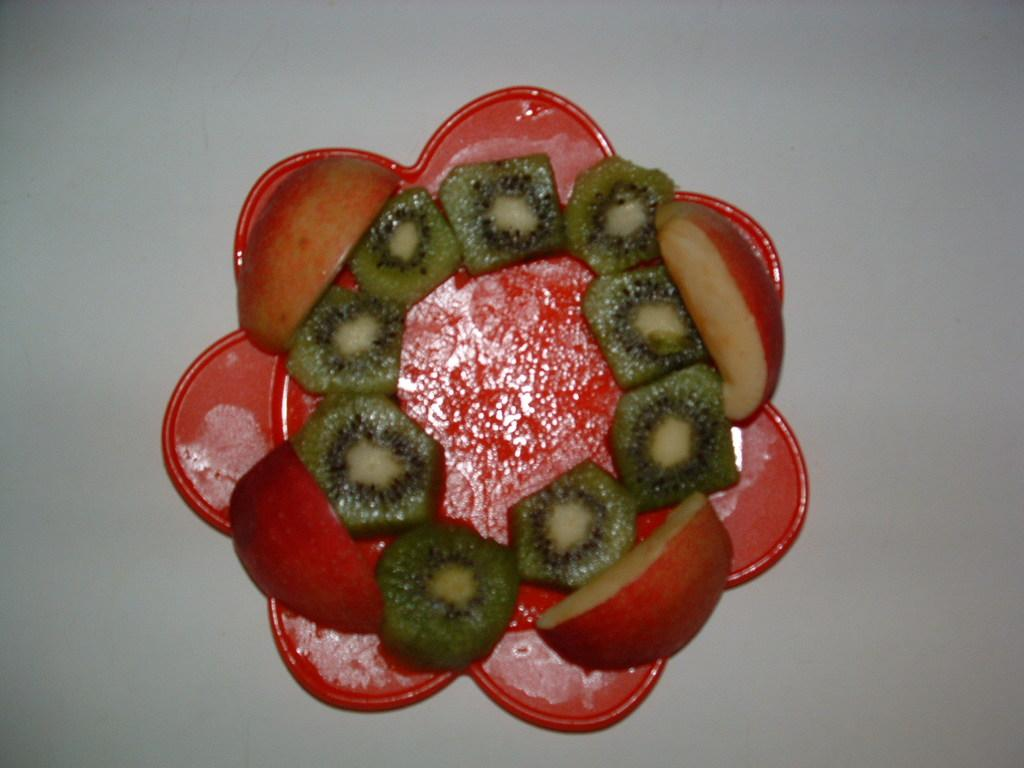What type of fruit is present on the plate in the image? There are apple slices and kiwi fruit slices on a plate in the image. Can you describe the object associated with the plate in the image? Unfortunately, the provided facts do not give enough information to describe the object associated with the plate. What type of guitar can be seen in the image? There is no guitar present in the image. How many eyes are visible on the flag in the image? There is no flag present in the image. 